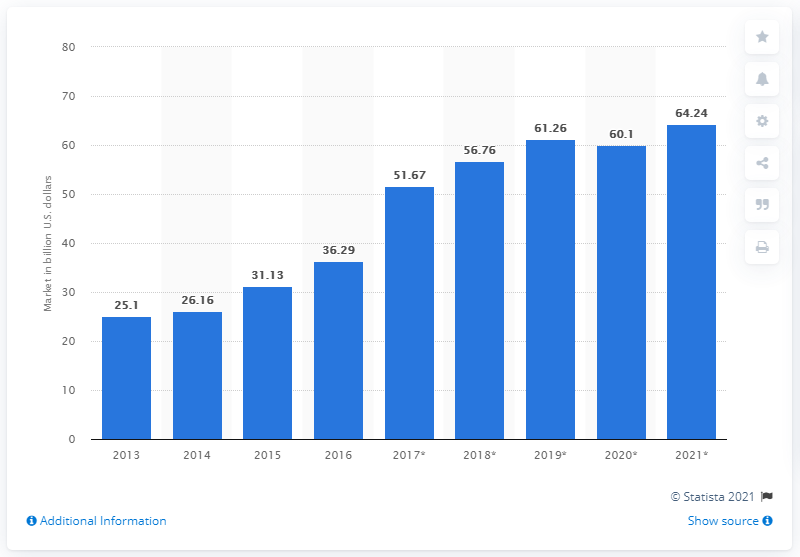Give some essential details in this illustration. In 2017, the estimated value of the global flash memory market was 51.67... 